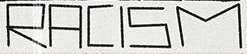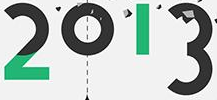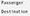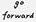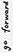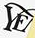Identify the words shown in these images in order, separated by a semicolon. RACISM; 2013; #; #; #; YE 